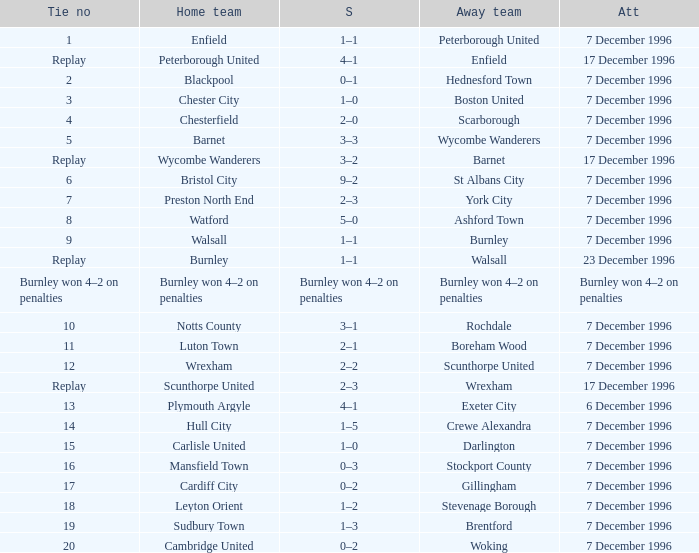What was the attendance for the home team of Walsall? 7 December 1996. 